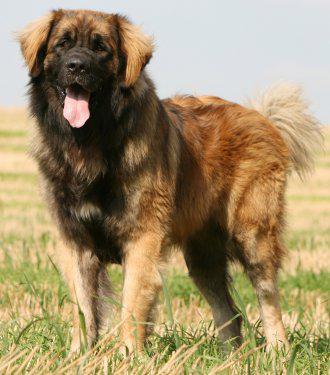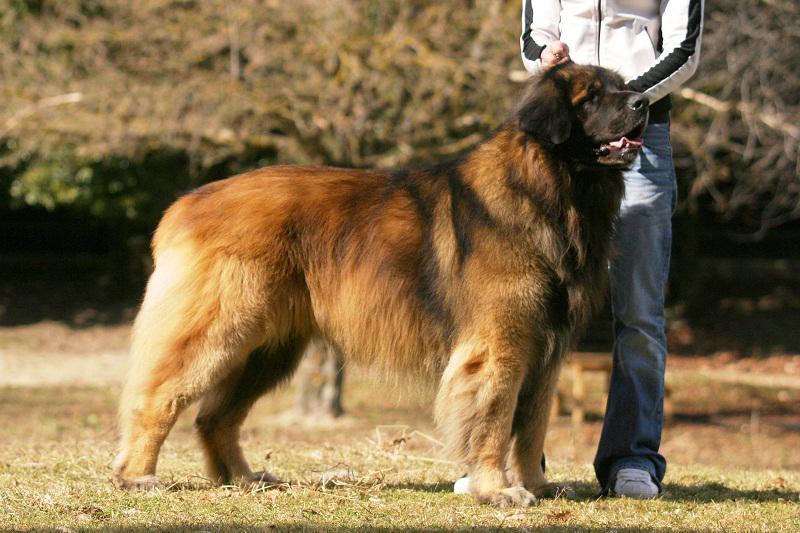The first image is the image on the left, the second image is the image on the right. Given the left and right images, does the statement "The dog's legs are not visible in any of the images." hold true? Answer yes or no. No. 